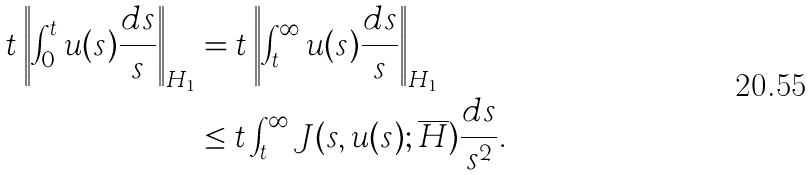<formula> <loc_0><loc_0><loc_500><loc_500>t \left \| \int _ { 0 } ^ { t } u ( s ) \frac { d s } { s } \right \| _ { H _ { 1 } } & = t \left \| \int _ { t } ^ { \infty } u ( s ) \frac { d s } { s } \right \| _ { H _ { 1 } } \\ & \leq t \int _ { t } ^ { \infty } J ( s , u ( s ) ; \overline { H } ) \frac { d s } { s ^ { 2 } } .</formula> 